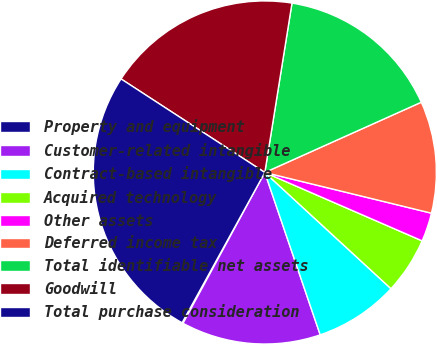<chart> <loc_0><loc_0><loc_500><loc_500><pie_chart><fcel>Property and equipment<fcel>Customer-related intangible<fcel>Contract-based intangible<fcel>Acquired technology<fcel>Other assets<fcel>Deferred income tax<fcel>Total identifiable net assets<fcel>Goodwill<fcel>Total purchase consideration<nl><fcel>0.1%<fcel>13.14%<fcel>7.92%<fcel>5.32%<fcel>2.71%<fcel>10.53%<fcel>15.75%<fcel>18.35%<fcel>26.17%<nl></chart> 